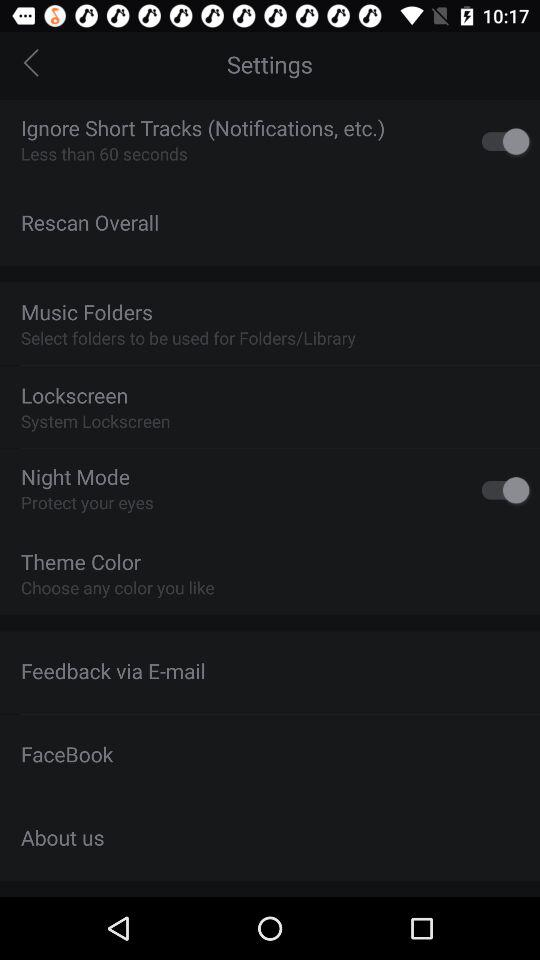What lock screen is selected? The selected lock screen is the system lockscreen. 